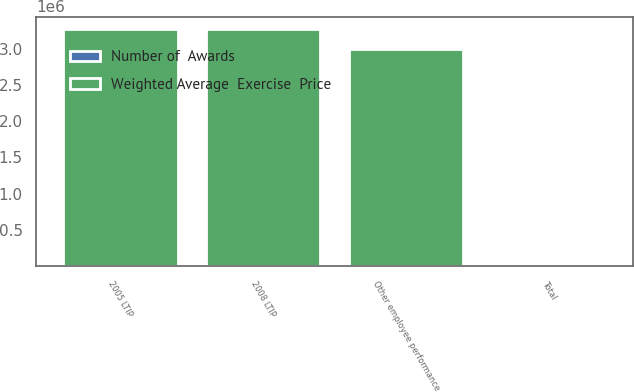Convert chart. <chart><loc_0><loc_0><loc_500><loc_500><stacked_bar_chart><ecel><fcel>2005 LTIP<fcel>2008 LTIP<fcel>Other employee performance<fcel>Total<nl><fcel>Weighted Average  Exercise  Price<fcel>3.2785e+06<fcel>3.27088e+06<fcel>3e+06<fcel>23.16<nl><fcel>Number of  Awards<fcel>22.92<fcel>11.84<fcel>23.16<fcel>19.2<nl></chart> 